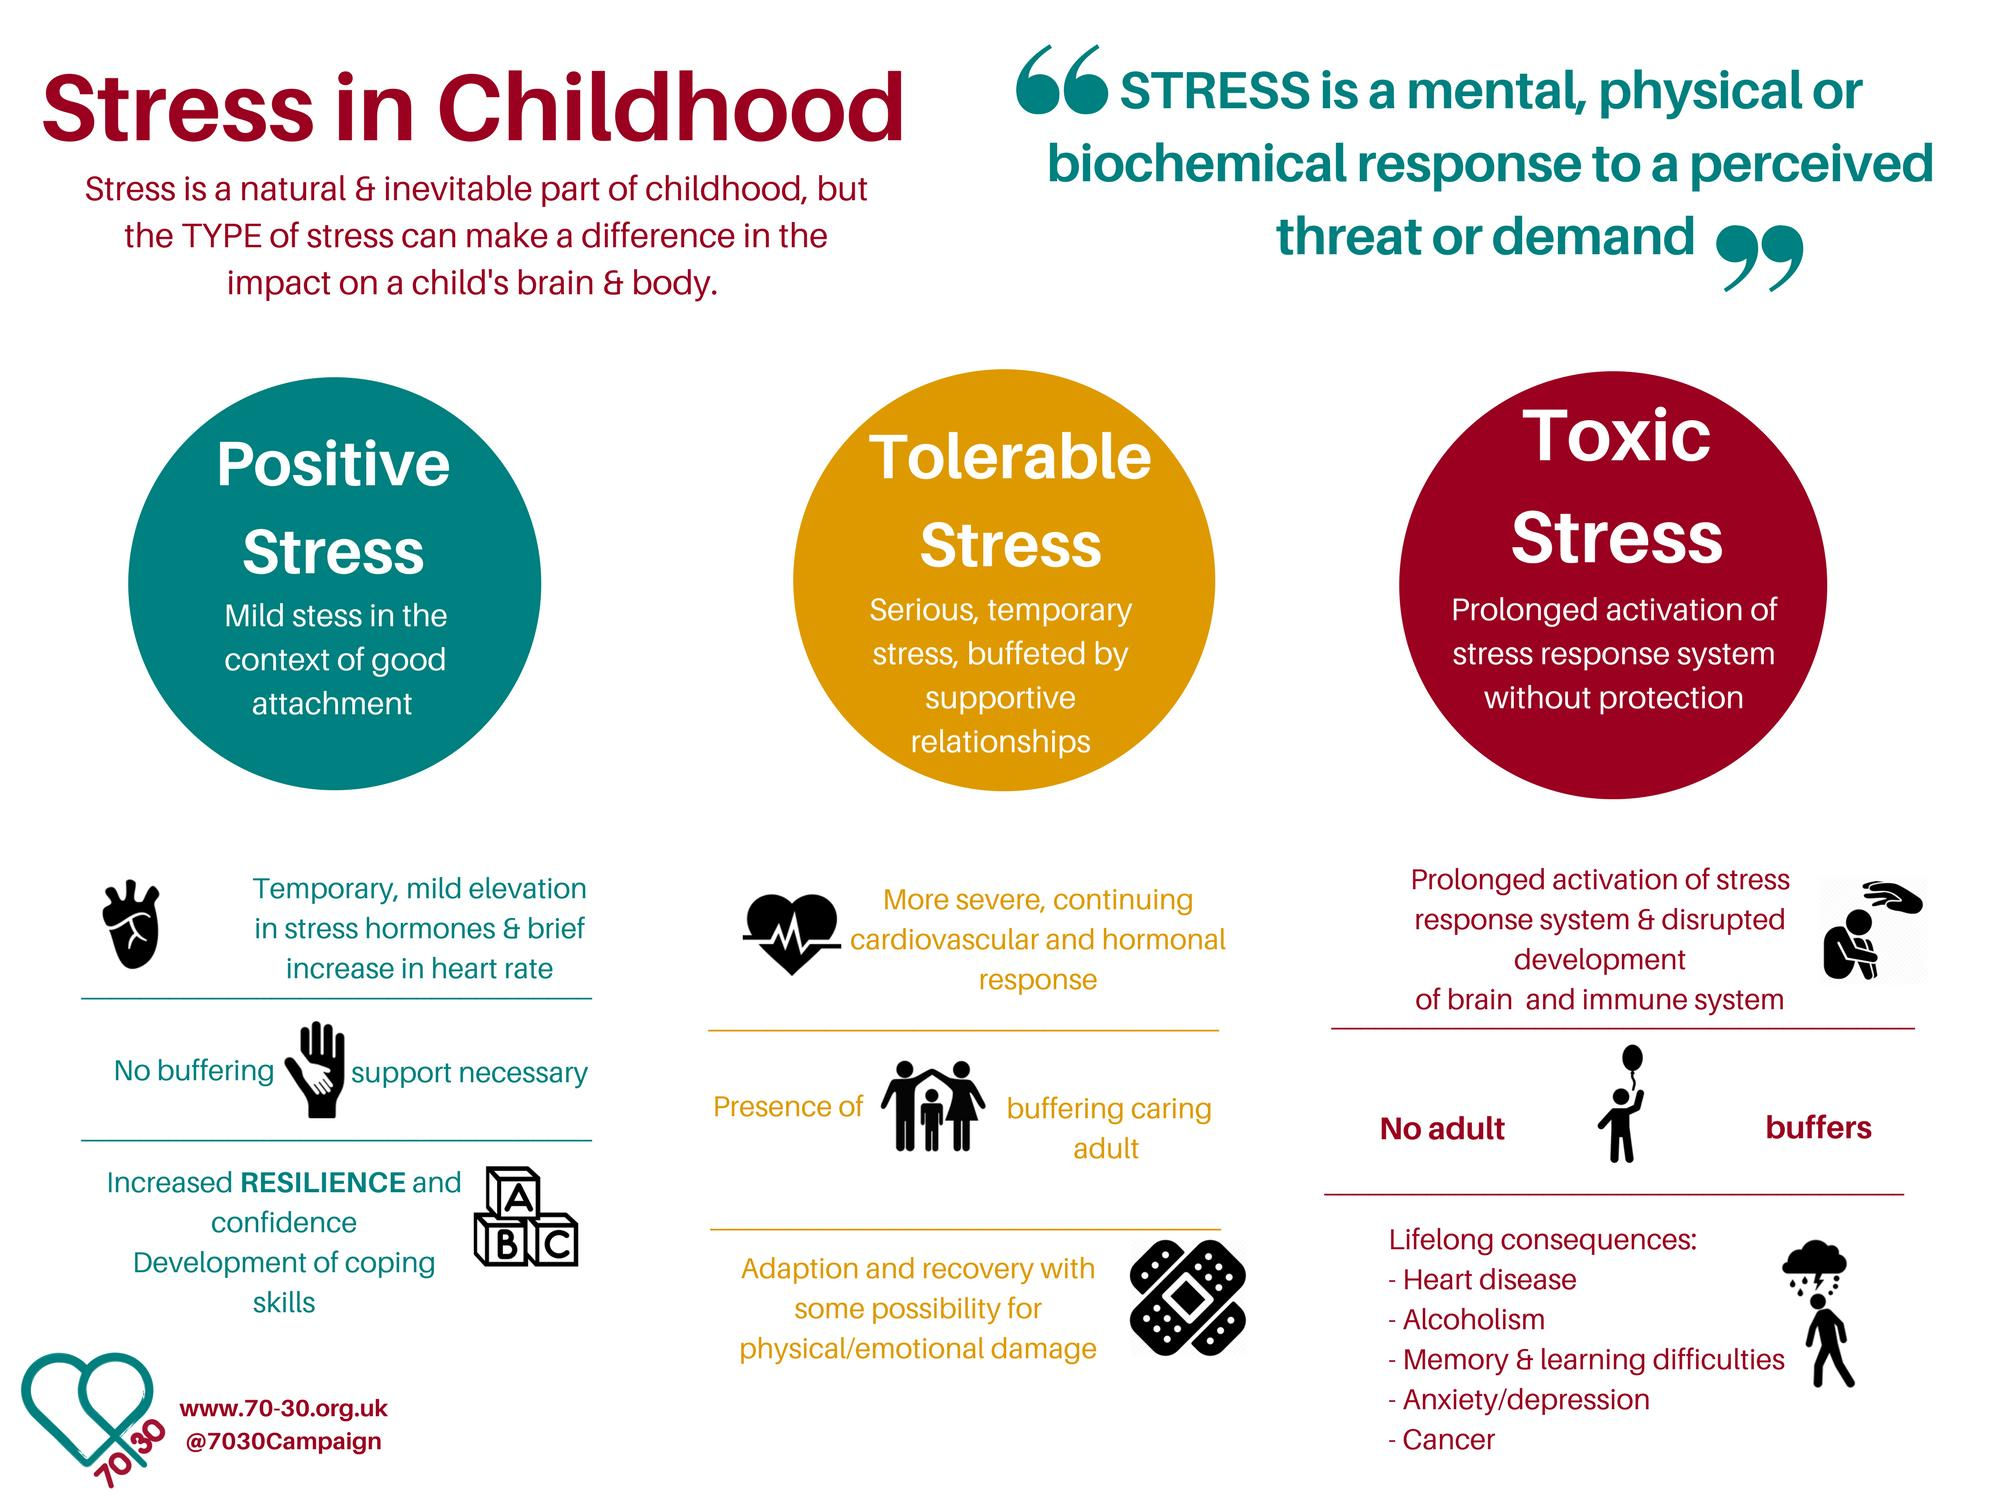Draw attention to some important aspects in this diagram. It is mentioned that there are various types of stresses, including positive stress, tolerable stress, and toxic stress. 